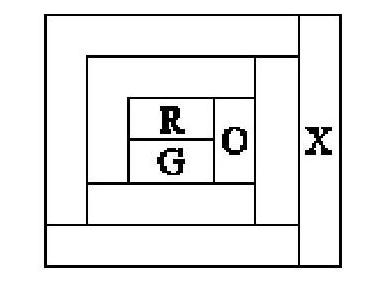Each area in the picture on the right should be coloured using one of the colours, red (R), green (G), blue (B) or orange (O). Areas which touch must be different colours. Which colour is the area marked $X? To determine the color of the area marked $X$, we must ensure it does not match the colors of the adjacent areas. Given that one area is already filled with red (R), and another with green (G), the area marked $X$ must be colored in a hue that is neither red nor green. The choices for coloring $X$ could be either blue (B) or orange (O). However, without additional context or adjacent areas, we cannot definitively determine the color. Therefore, the answer is 'The colour cannot definitely be determined.' 